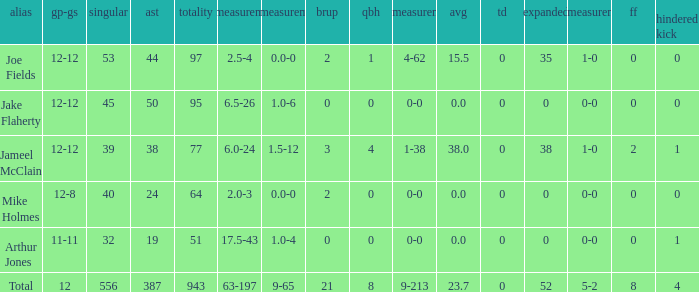What is the largest number of tds scored for a player? 0.0. 